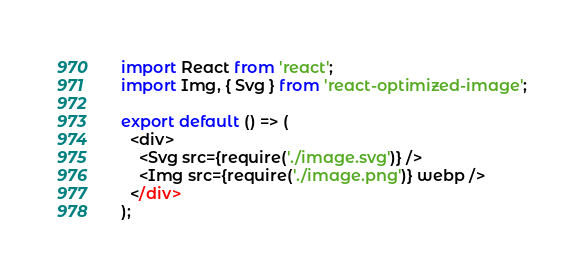Convert code to text. <code><loc_0><loc_0><loc_500><loc_500><_JavaScript_>import React from 'react';
import Img, { Svg } from 'react-optimized-image';

export default () => (
  <div>
    <Svg src={require('./image.svg')} />
    <Img src={require('./image.png')} webp />
  </div>
);
</code> 